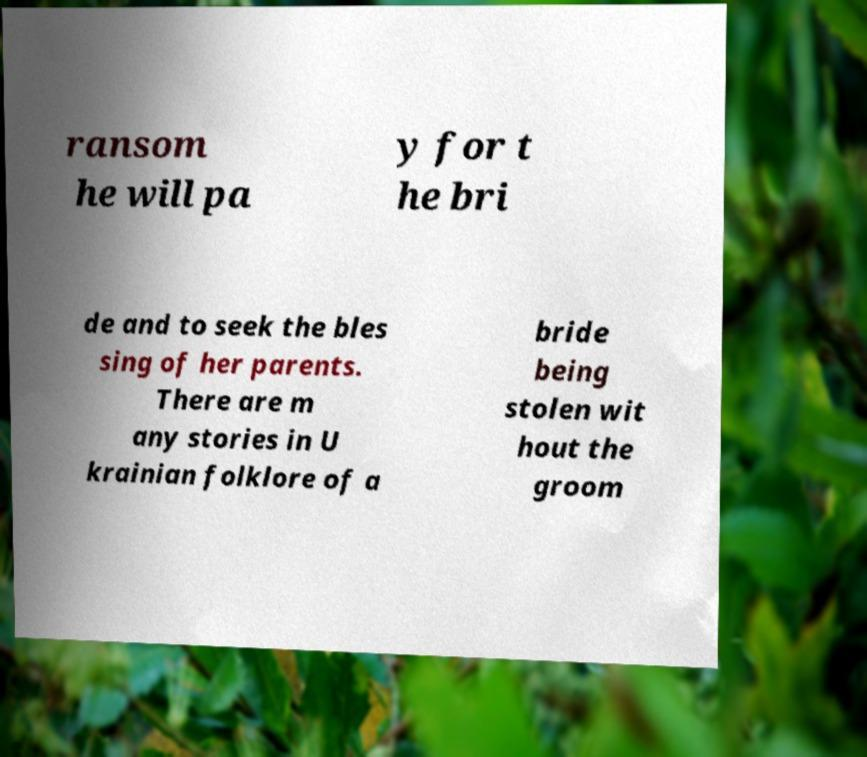For documentation purposes, I need the text within this image transcribed. Could you provide that? ransom he will pa y for t he bri de and to seek the bles sing of her parents. There are m any stories in U krainian folklore of a bride being stolen wit hout the groom 